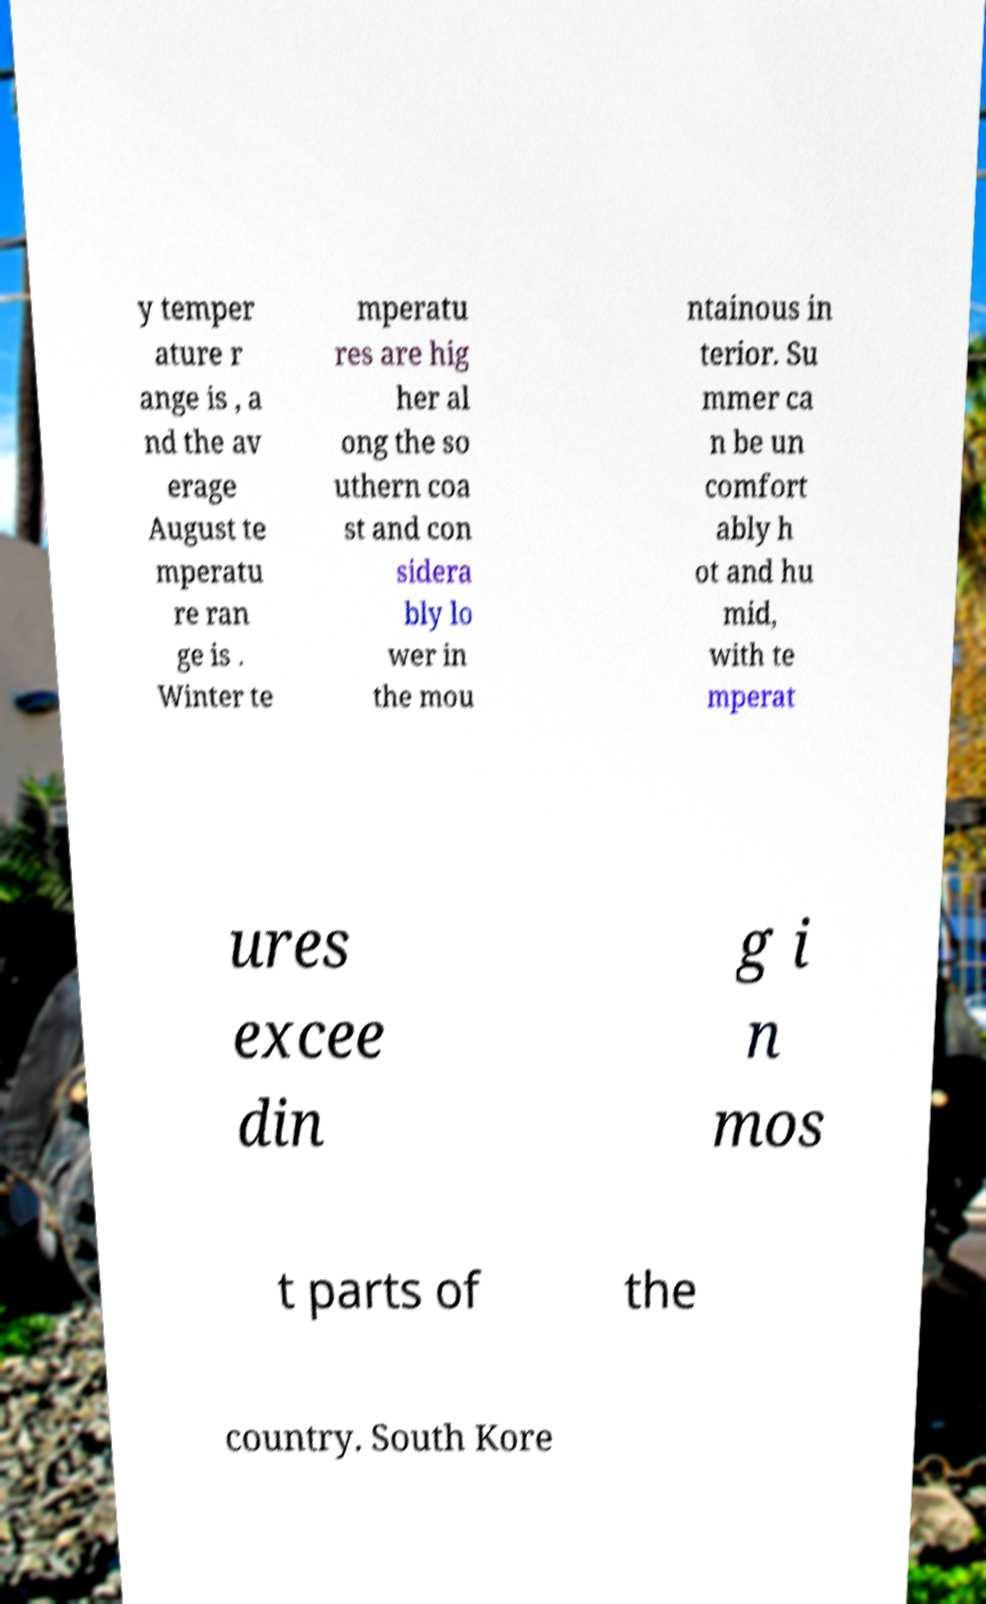Please identify and transcribe the text found in this image. y temper ature r ange is , a nd the av erage August te mperatu re ran ge is . Winter te mperatu res are hig her al ong the so uthern coa st and con sidera bly lo wer in the mou ntainous in terior. Su mmer ca n be un comfort ably h ot and hu mid, with te mperat ures excee din g i n mos t parts of the country. South Kore 